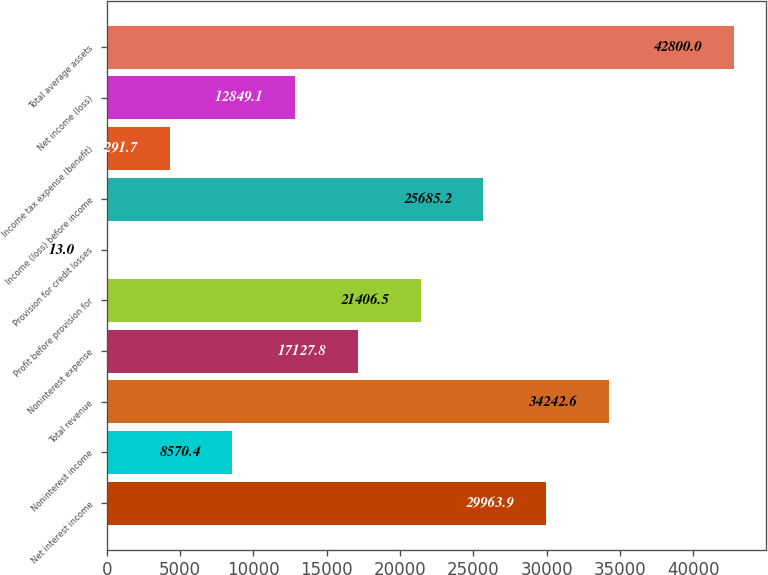Convert chart. <chart><loc_0><loc_0><loc_500><loc_500><bar_chart><fcel>Net interest income<fcel>Noninterest income<fcel>Total revenue<fcel>Noninterest expense<fcel>Profit before provision for<fcel>Provision for credit losses<fcel>Income (loss) before income<fcel>Income tax expense (benefit)<fcel>Net income (loss)<fcel>Total average assets<nl><fcel>29963.9<fcel>8570.4<fcel>34242.6<fcel>17127.8<fcel>21406.5<fcel>13<fcel>25685.2<fcel>4291.7<fcel>12849.1<fcel>42800<nl></chart> 